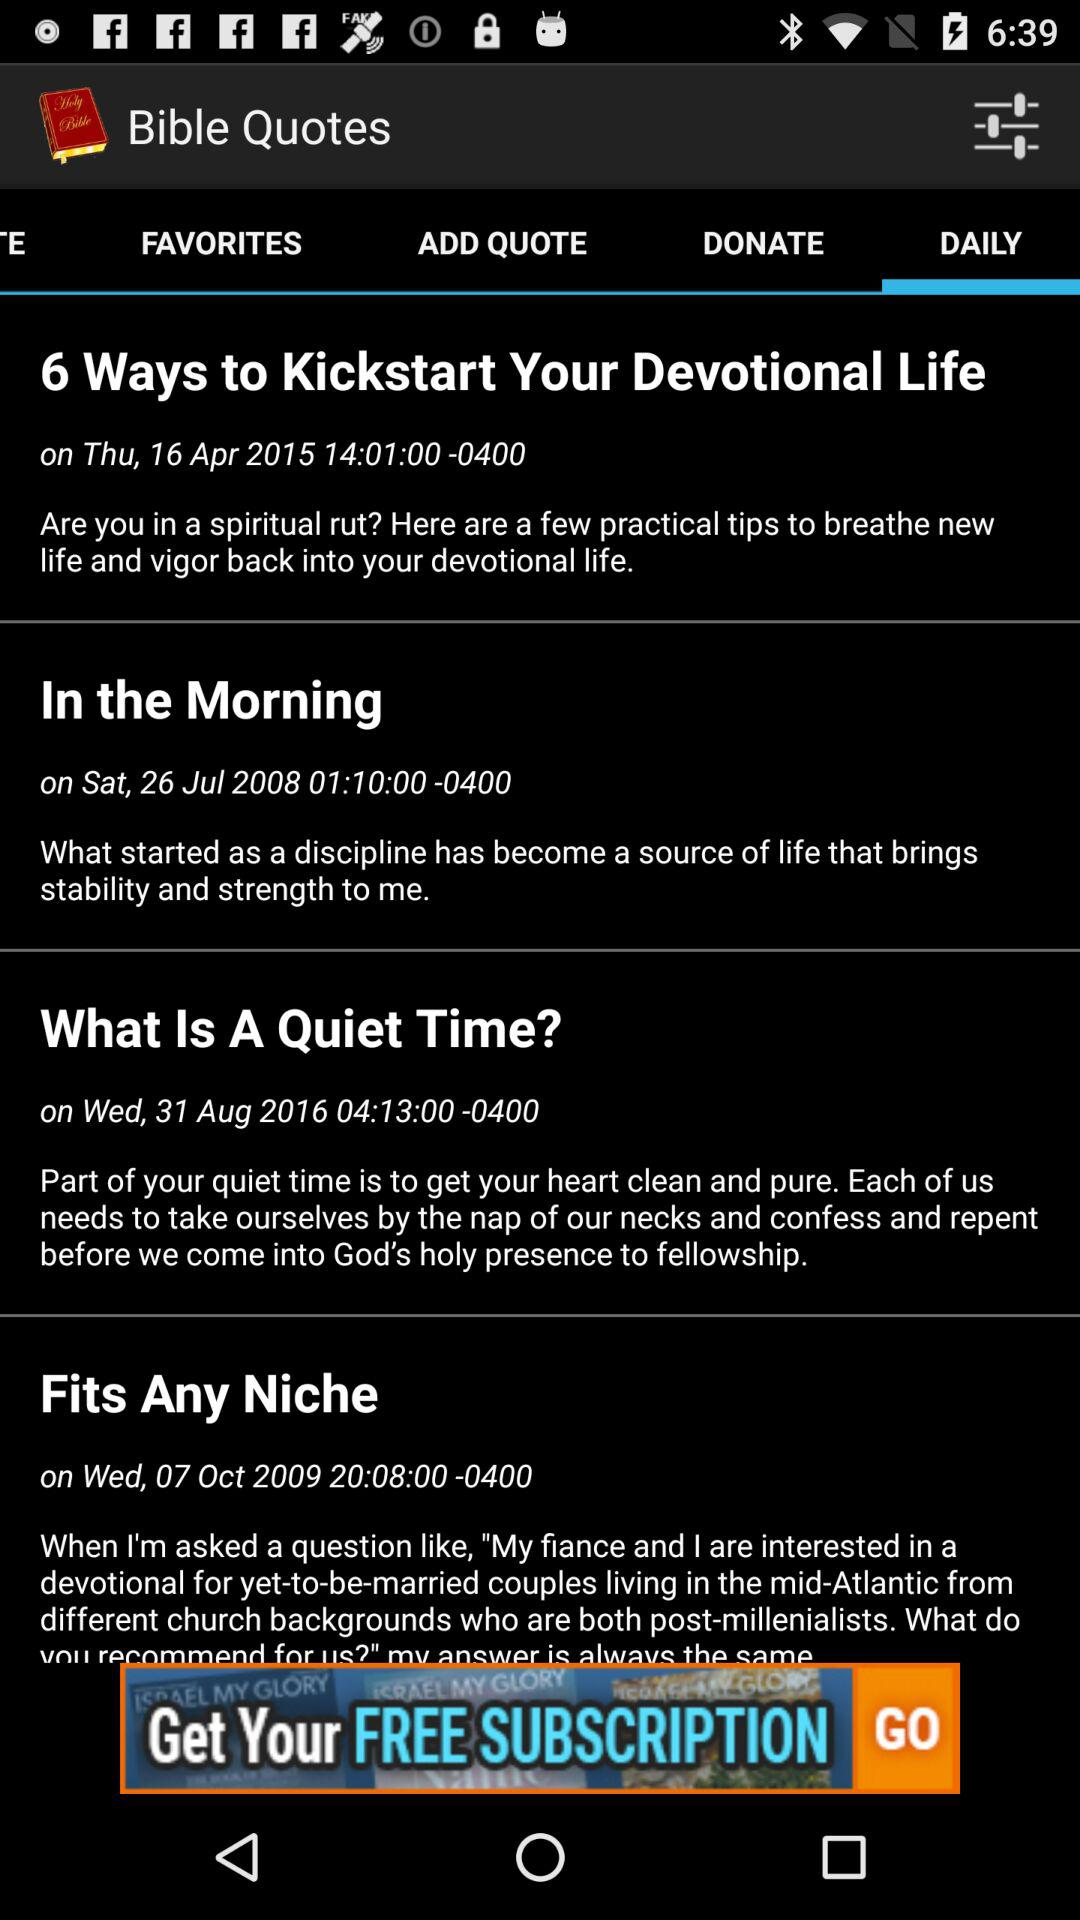Who wrote "Fits Any Niche"?
When the provided information is insufficient, respond with <no answer>. <no answer> 